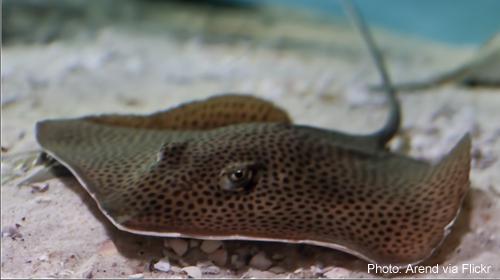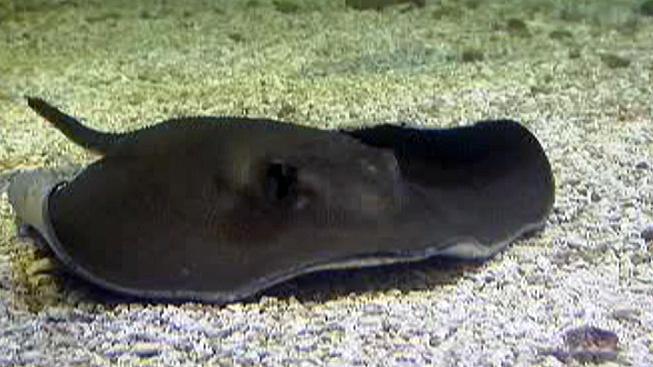The first image is the image on the left, the second image is the image on the right. Assess this claim about the two images: "The left and right image contains the same number of stingrays swimming facing slightly different directions.". Correct or not? Answer yes or no. Yes. The first image is the image on the left, the second image is the image on the right. Examine the images to the left and right. Is the description "All the rays are under water." accurate? Answer yes or no. Yes. 